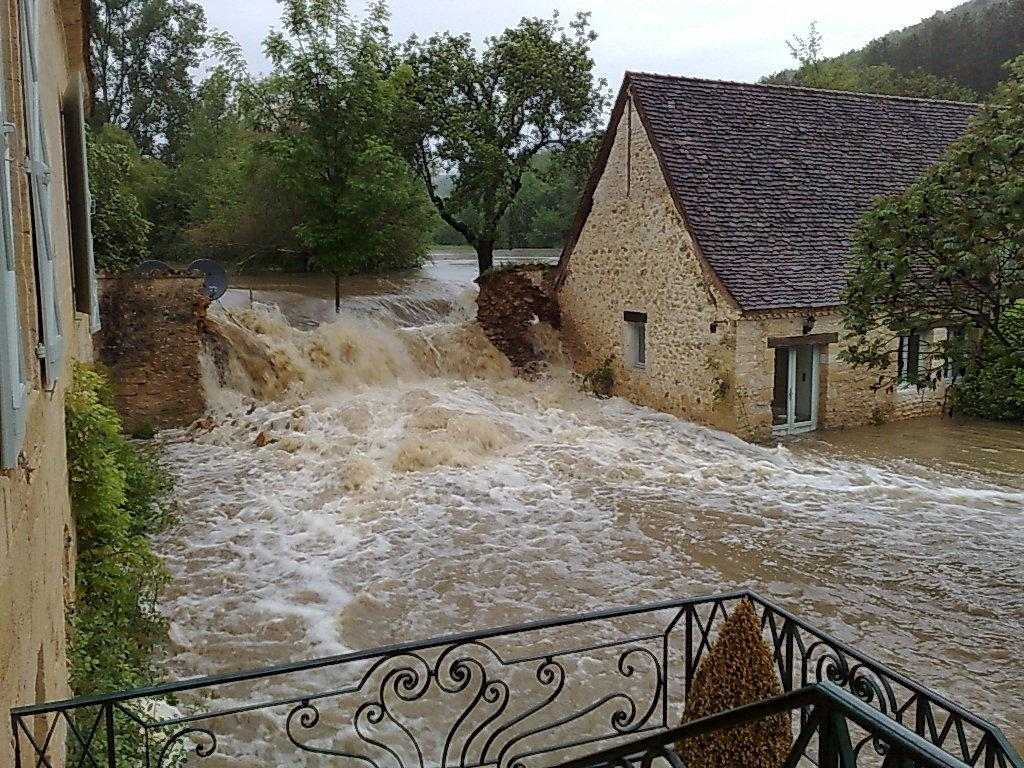What is located in the middle of the image? There are trees and water in the middle of the image. What is the condition of the water in the image? Waves are present in the water. What type of structures can be seen in the image? There are buildings and a house in the image. What is visible at the bottom of the image? Railings and a plant are visible at the bottom of the image. What can be seen in the background of the image? There are hills and the sky in the background of the image. How many pets are sitting on the chair in the image? There are no pets or chairs present in the image. What type of family can be seen in the image? There is: There is no family depicted in the image; it features trees, water, buildings, and other landscape elements. 